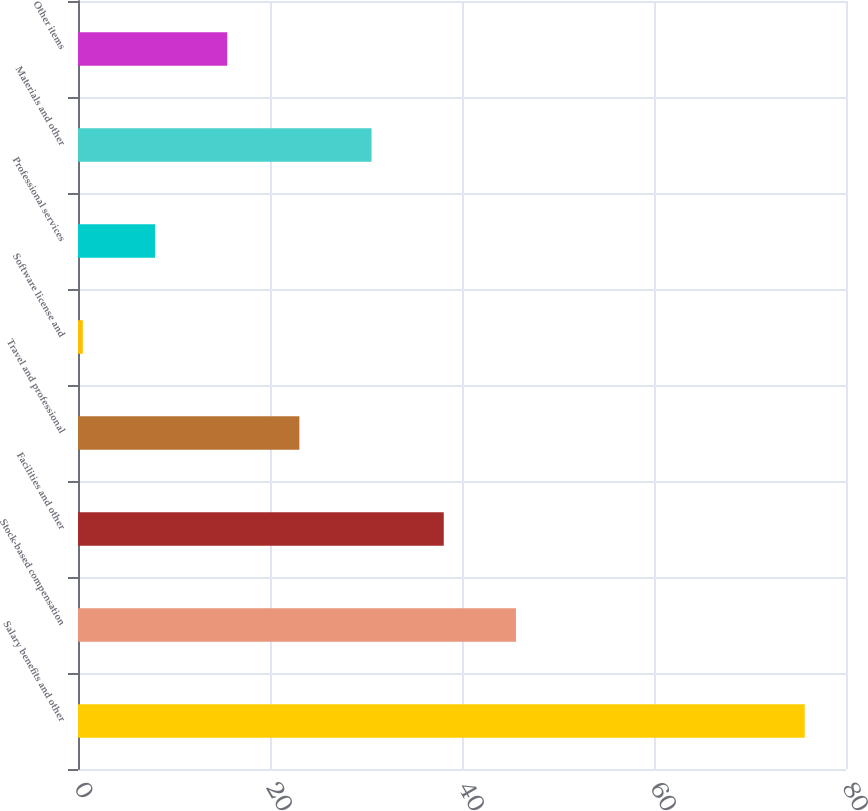<chart> <loc_0><loc_0><loc_500><loc_500><bar_chart><fcel>Salary benefits and other<fcel>Stock-based compensation<fcel>Facilities and other<fcel>Travel and professional<fcel>Software license and<fcel>Professional services<fcel>Materials and other<fcel>Other items<nl><fcel>75.7<fcel>45.62<fcel>38.1<fcel>23.06<fcel>0.5<fcel>8.02<fcel>30.58<fcel>15.54<nl></chart> 